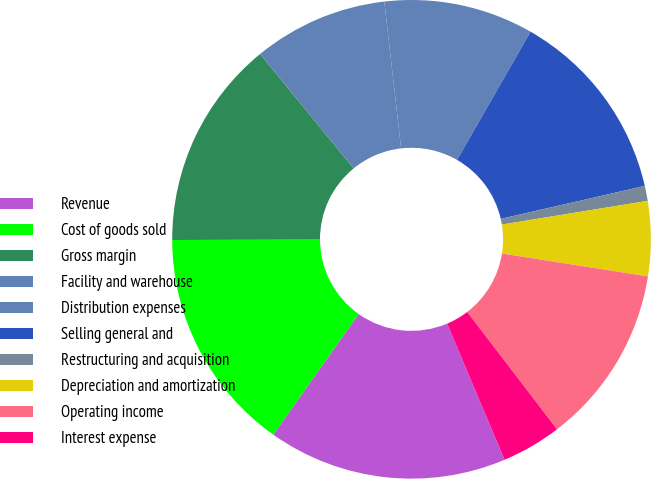Convert chart. <chart><loc_0><loc_0><loc_500><loc_500><pie_chart><fcel>Revenue<fcel>Cost of goods sold<fcel>Gross margin<fcel>Facility and warehouse<fcel>Distribution expenses<fcel>Selling general and<fcel>Restructuring and acquisition<fcel>Depreciation and amortization<fcel>Operating income<fcel>Interest expense<nl><fcel>16.16%<fcel>15.15%<fcel>14.14%<fcel>9.09%<fcel>10.1%<fcel>13.13%<fcel>1.01%<fcel>5.05%<fcel>12.12%<fcel>4.04%<nl></chart> 